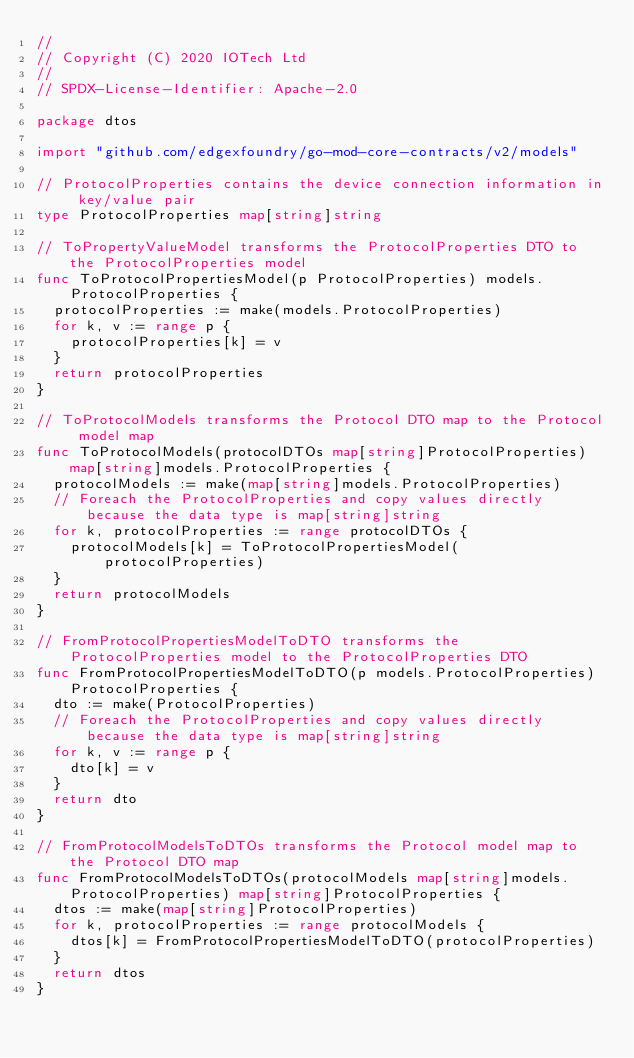Convert code to text. <code><loc_0><loc_0><loc_500><loc_500><_Go_>//
// Copyright (C) 2020 IOTech Ltd
//
// SPDX-License-Identifier: Apache-2.0

package dtos

import "github.com/edgexfoundry/go-mod-core-contracts/v2/models"

// ProtocolProperties contains the device connection information in key/value pair
type ProtocolProperties map[string]string

// ToPropertyValueModel transforms the ProtocolProperties DTO to the ProtocolProperties model
func ToProtocolPropertiesModel(p ProtocolProperties) models.ProtocolProperties {
	protocolProperties := make(models.ProtocolProperties)
	for k, v := range p {
		protocolProperties[k] = v
	}
	return protocolProperties
}

// ToProtocolModels transforms the Protocol DTO map to the Protocol model map
func ToProtocolModels(protocolDTOs map[string]ProtocolProperties) map[string]models.ProtocolProperties {
	protocolModels := make(map[string]models.ProtocolProperties)
	// Foreach the ProtocolProperties and copy values directly because the data type is map[string]string
	for k, protocolProperties := range protocolDTOs {
		protocolModels[k] = ToProtocolPropertiesModel(protocolProperties)
	}
	return protocolModels
}

// FromProtocolPropertiesModelToDTO transforms the ProtocolProperties model to the ProtocolProperties DTO
func FromProtocolPropertiesModelToDTO(p models.ProtocolProperties) ProtocolProperties {
	dto := make(ProtocolProperties)
	// Foreach the ProtocolProperties and copy values directly because the data type is map[string]string
	for k, v := range p {
		dto[k] = v
	}
	return dto
}

// FromProtocolModelsToDTOs transforms the Protocol model map to the Protocol DTO map
func FromProtocolModelsToDTOs(protocolModels map[string]models.ProtocolProperties) map[string]ProtocolProperties {
	dtos := make(map[string]ProtocolProperties)
	for k, protocolProperties := range protocolModels {
		dtos[k] = FromProtocolPropertiesModelToDTO(protocolProperties)
	}
	return dtos
}
</code> 